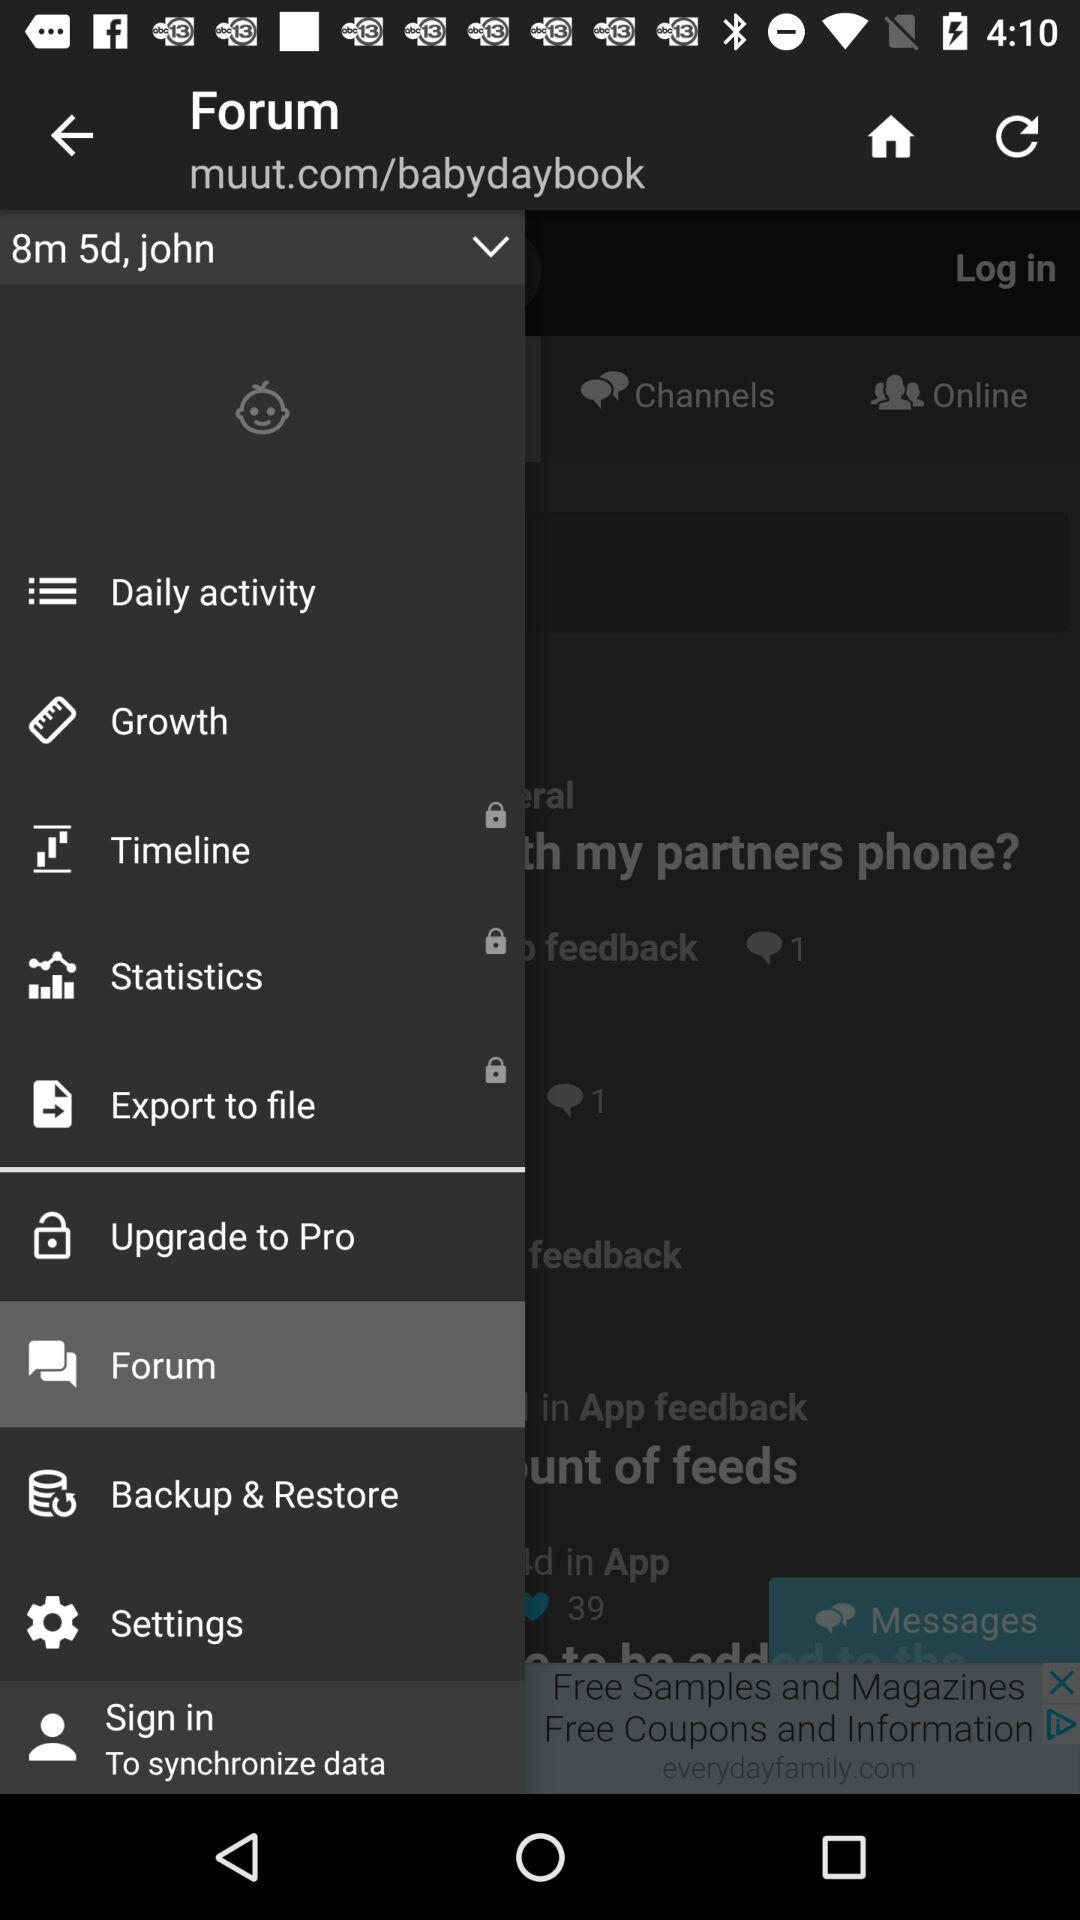What is the baby's name? The name of the baby is John. 